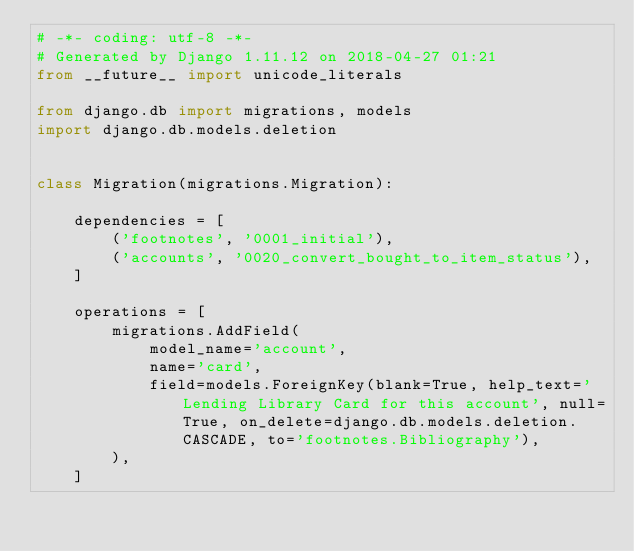Convert code to text. <code><loc_0><loc_0><loc_500><loc_500><_Python_># -*- coding: utf-8 -*-
# Generated by Django 1.11.12 on 2018-04-27 01:21
from __future__ import unicode_literals

from django.db import migrations, models
import django.db.models.deletion


class Migration(migrations.Migration):

    dependencies = [
        ('footnotes', '0001_initial'),
        ('accounts', '0020_convert_bought_to_item_status'),
    ]

    operations = [
        migrations.AddField(
            model_name='account',
            name='card',
            field=models.ForeignKey(blank=True, help_text='Lending Library Card for this account', null=True, on_delete=django.db.models.deletion.CASCADE, to='footnotes.Bibliography'),
        ),
    ]
</code> 